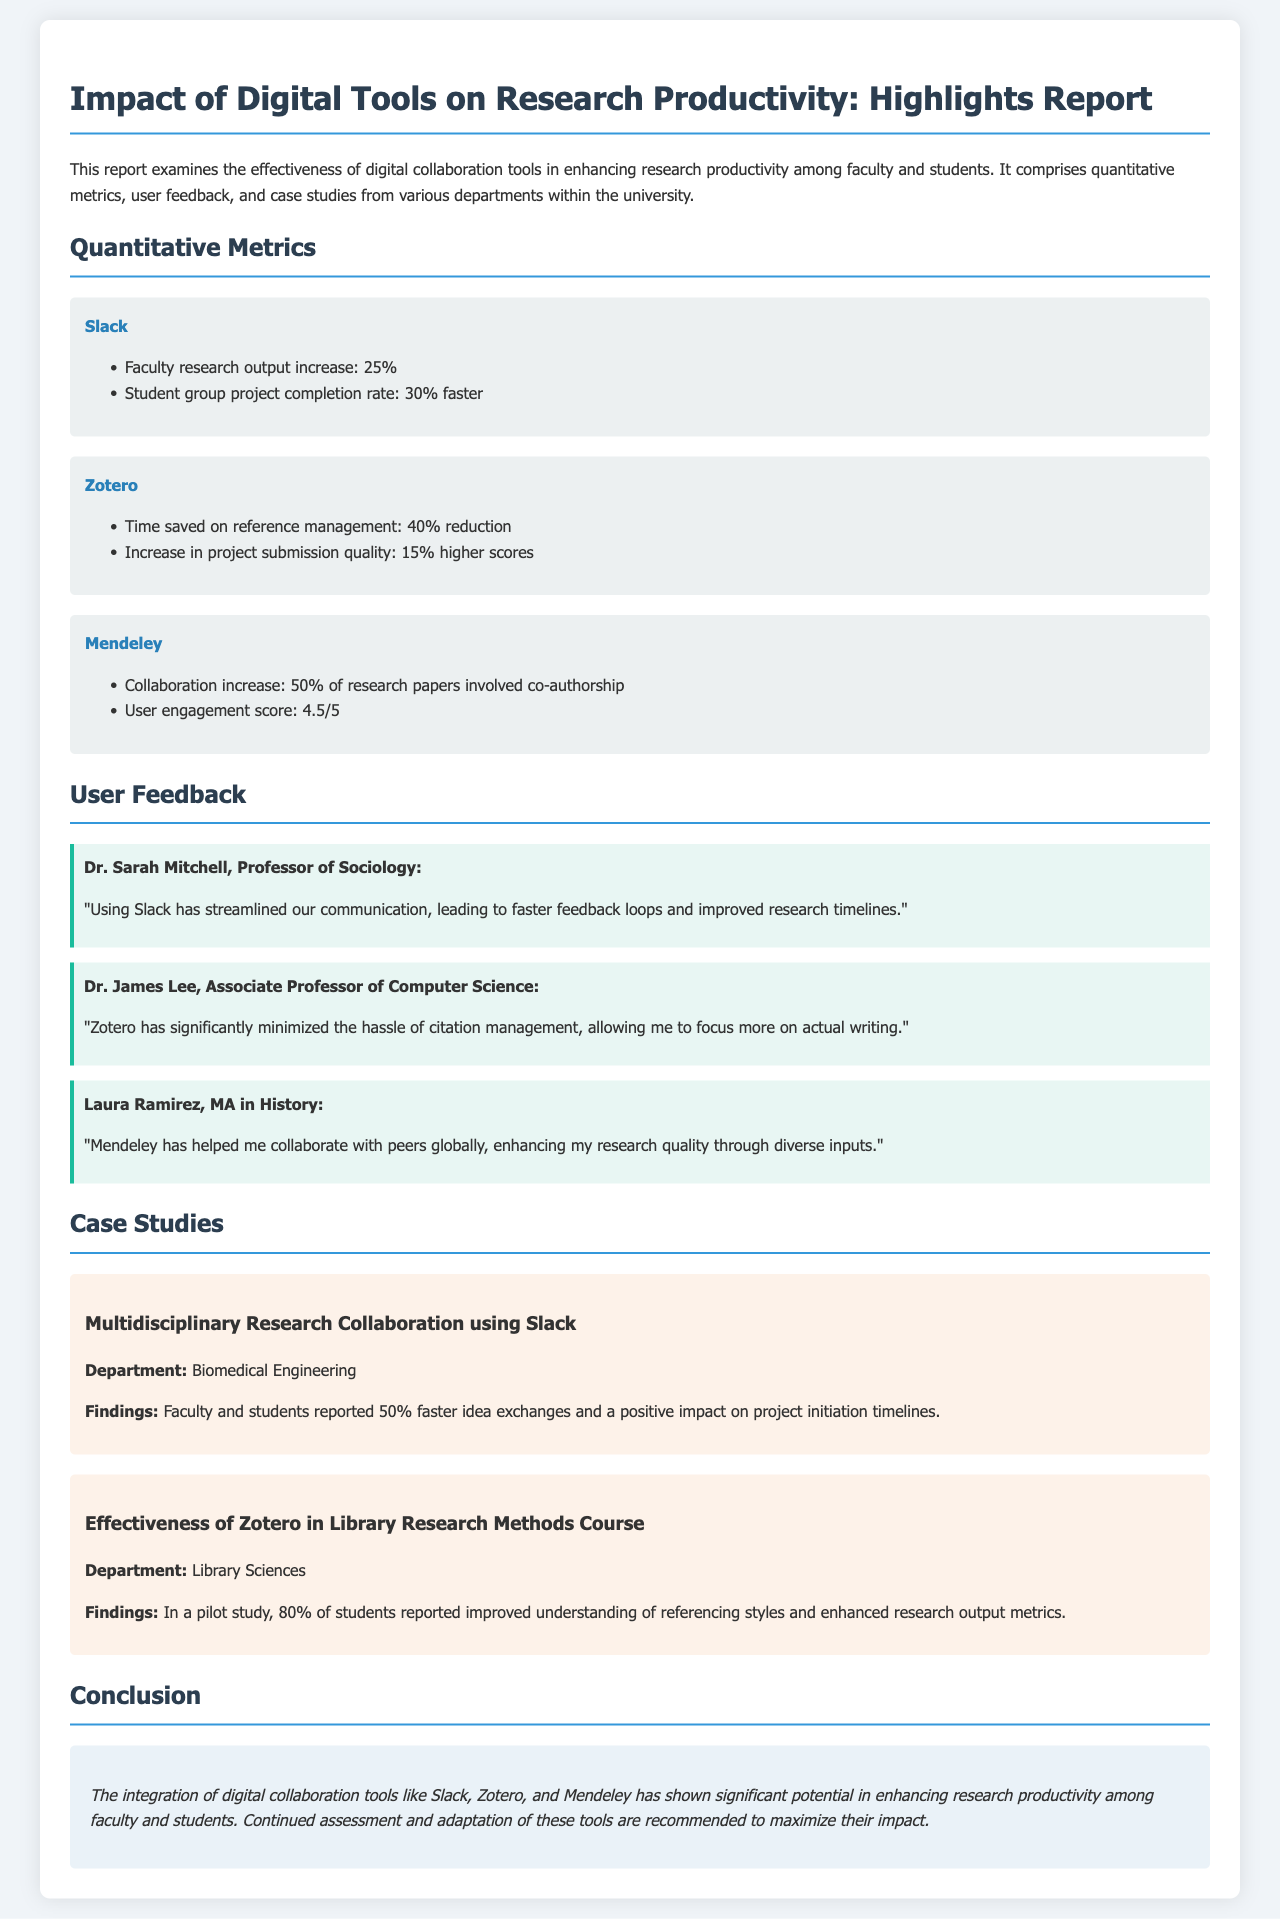What digital collaboration tool saw a 25% increase in faculty research output? The tool that saw a 25% increase in faculty research output is Slack.
Answer: Slack What percentage increase in project submission quality is associated with Zotero? Zotero is associated with a 15% higher scores in project submission quality.
Answer: 15% What was the user engagement score for Mendeley? The user engagement score for Mendeley is 4.5 out of 5.
Answer: 4.5/5 Which department reported a 50% faster idea exchange using Slack? The department that reported a 50% faster idea exchange using Slack is Biomedical Engineering.
Answer: Biomedical Engineering How many students reported improved understanding of referencing styles in the Zotero case study? In the Zotero case study, 80% of students reported improved understanding of referencing styles.
Answer: 80% What did Dr. Sarah Mitchell emphasize about Slack in her feedback? Dr. Sarah Mitchell emphasized that Slack has streamlined communication, leading to faster feedback loops.
Answer: Streamlined communication How much time was saved on reference management when using Zotero? The time saved on reference management when using Zotero is a 40% reduction.
Answer: 40% What is the overall conclusion regarding digital collaboration tools in the report? The overall conclusion is that the integration of digital collaboration tools has significant potential in enhancing research productivity.
Answer: Significant potential What is the main focus of the report? The main focus of the report is examining the effectiveness of digital collaboration tools in enhancing research productivity.
Answer: Effectiveness of digital collaboration tools 